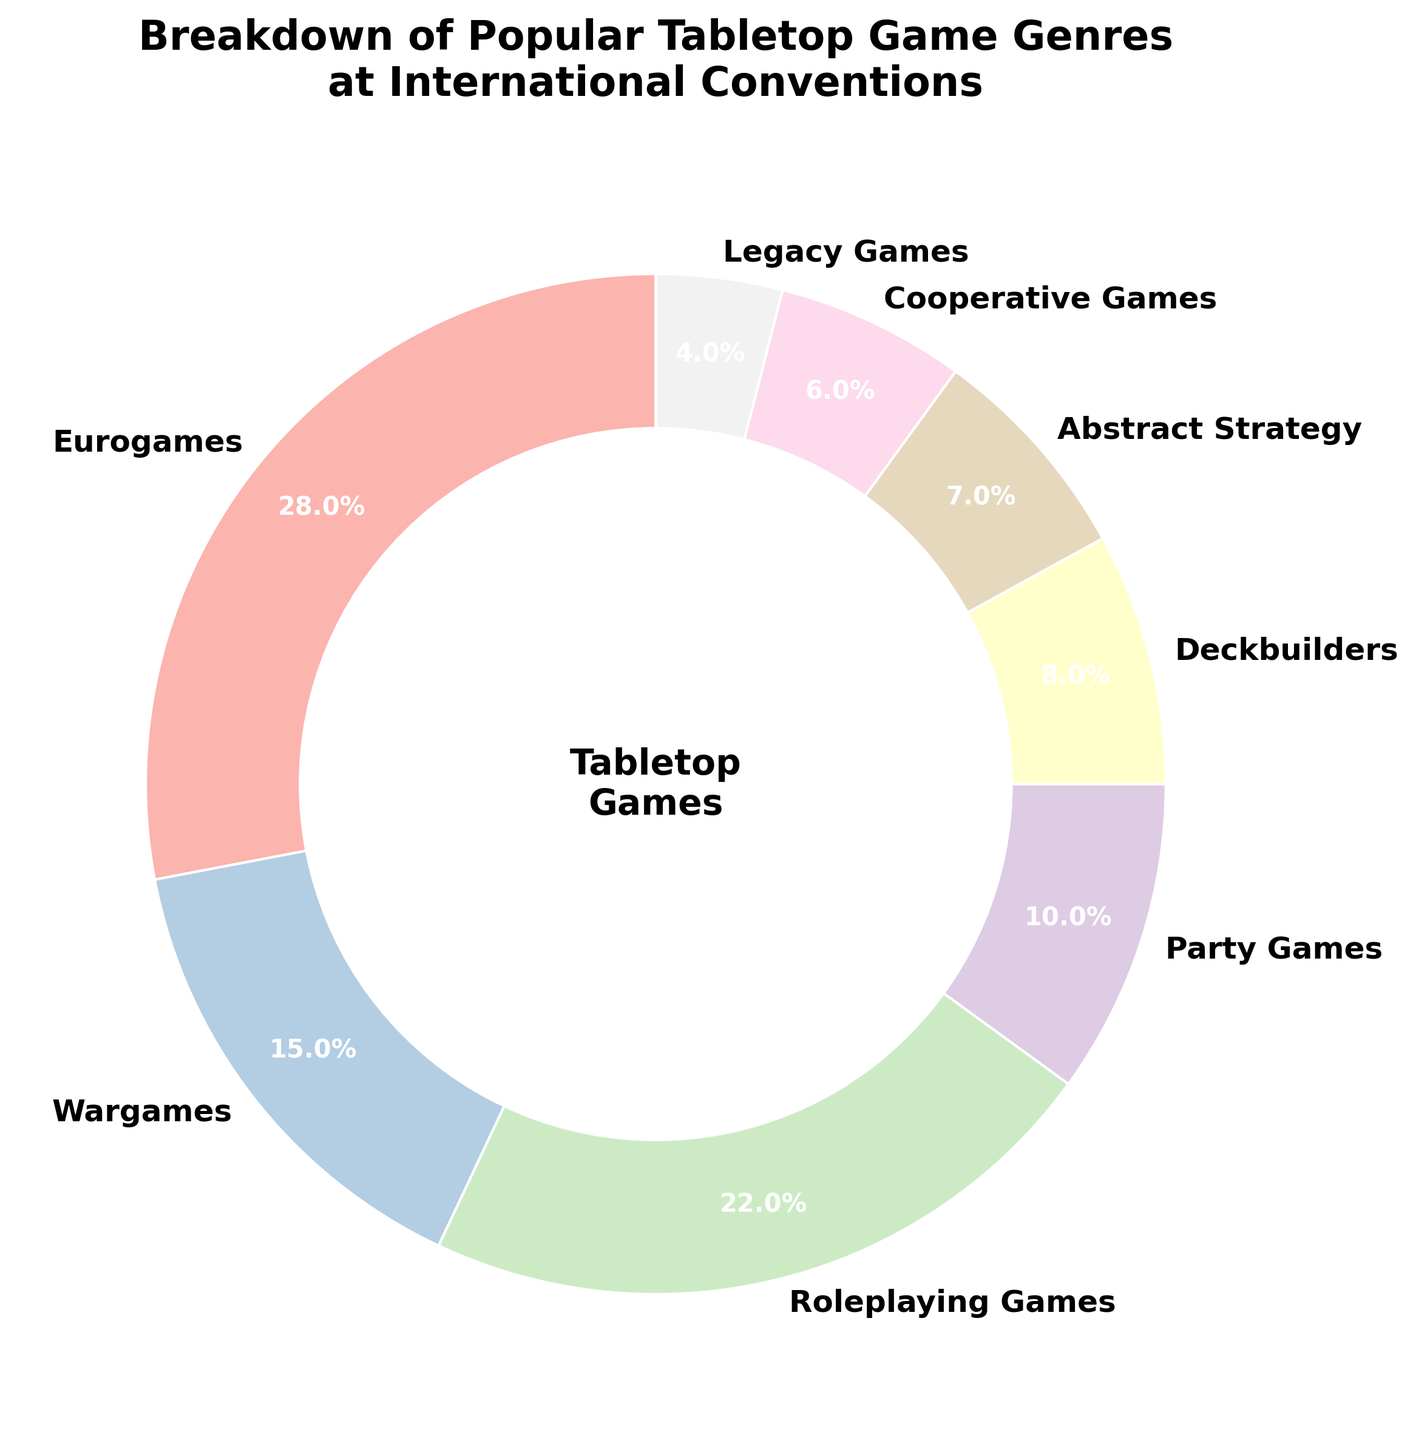What genre has the highest percentage? The genre with the highest percentage is determined by looking at the pie chart for the largest section. Eurogames occupy the largest section with a percentage of 28%.
Answer: Eurogames Which two genres have the lowest combined percentage? First, identify the genres with the lowest percentages which are Cooperative Games (6%) and Legacy Games (4%). Add these two values together: 6 + 4 = 10%.
Answer: Cooperative Games and Legacy Games How much larger is the percentage of Eurogames compared to Deckbuilders? First, find the percentages for Eurogames (28%) and Deckbuilders (8%). Then, subtract Deckbuilders percentage from Eurogames percentage: 28 - 8 = 20%.
Answer: 20% Which genre has a middle-sized segment (neither the largest nor the smallest)? Identify the percentages to find the ones in the middle range. Roleplaying Games (22%) fits this description as it is neither the largest (Eurogames with 28%) nor the smallest (Legacy Games with 4%).
Answer: Roleplaying Games What is the sum of the percentages for Wargames and Party Games? Sum up the percentages for Wargames (15%) and Party Games (10%): 15 + 10 = 25%.
Answer: 25% What percentage of the pie chart is covered by genres under 10%? Identify genres under 10%: Party Games (10%), Deckbuilders (8%), Abstract Strategy (7%), Cooperative Games (6%), and Legacy Games (4%) then sum these percentages: 10 + 8 + 7 + 6 + 4 = 35%.
Answer: 35% Which genre has the third largest percentage? First rank the genres by percentage. The third largest genre is Roleplaying Games with 22%.
Answer: Roleplaying Games Out of Roleplaying Games and Wargames, which genre has a higher percentage? Compare the percentages of Roleplaying Games (22%) and Wargames (15%). Roleplaying Games have a higher percentage.
Answer: Roleplaying Games What is the average percentage of the top three genres? Identify the top three genres by percentage: Eurogames (28%), Roleplaying Games (22%), and Wargames (15%). Compute the average: (28 + 22 + 15) / 3 = 21.67%.
Answer: 21.67% If Cooperative Games and Legacy Games were combined into one category, what would its percentage be? Sum the percentages for Cooperative Games (6%) and Legacy Games (4%): 6 + 4 = 10%.
Answer: 10% 